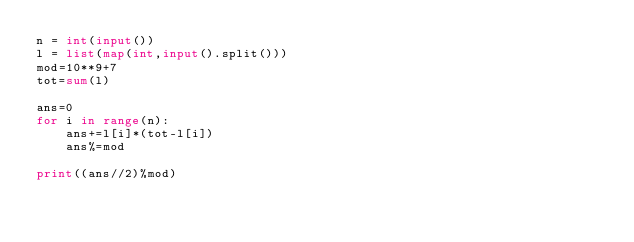Convert code to text. <code><loc_0><loc_0><loc_500><loc_500><_Python_>n = int(input())
l = list(map(int,input().split()))
mod=10**9+7
tot=sum(l)

ans=0
for i in range(n):
    ans+=l[i]*(tot-l[i])
    ans%=mod

print((ans//2)%mod)</code> 